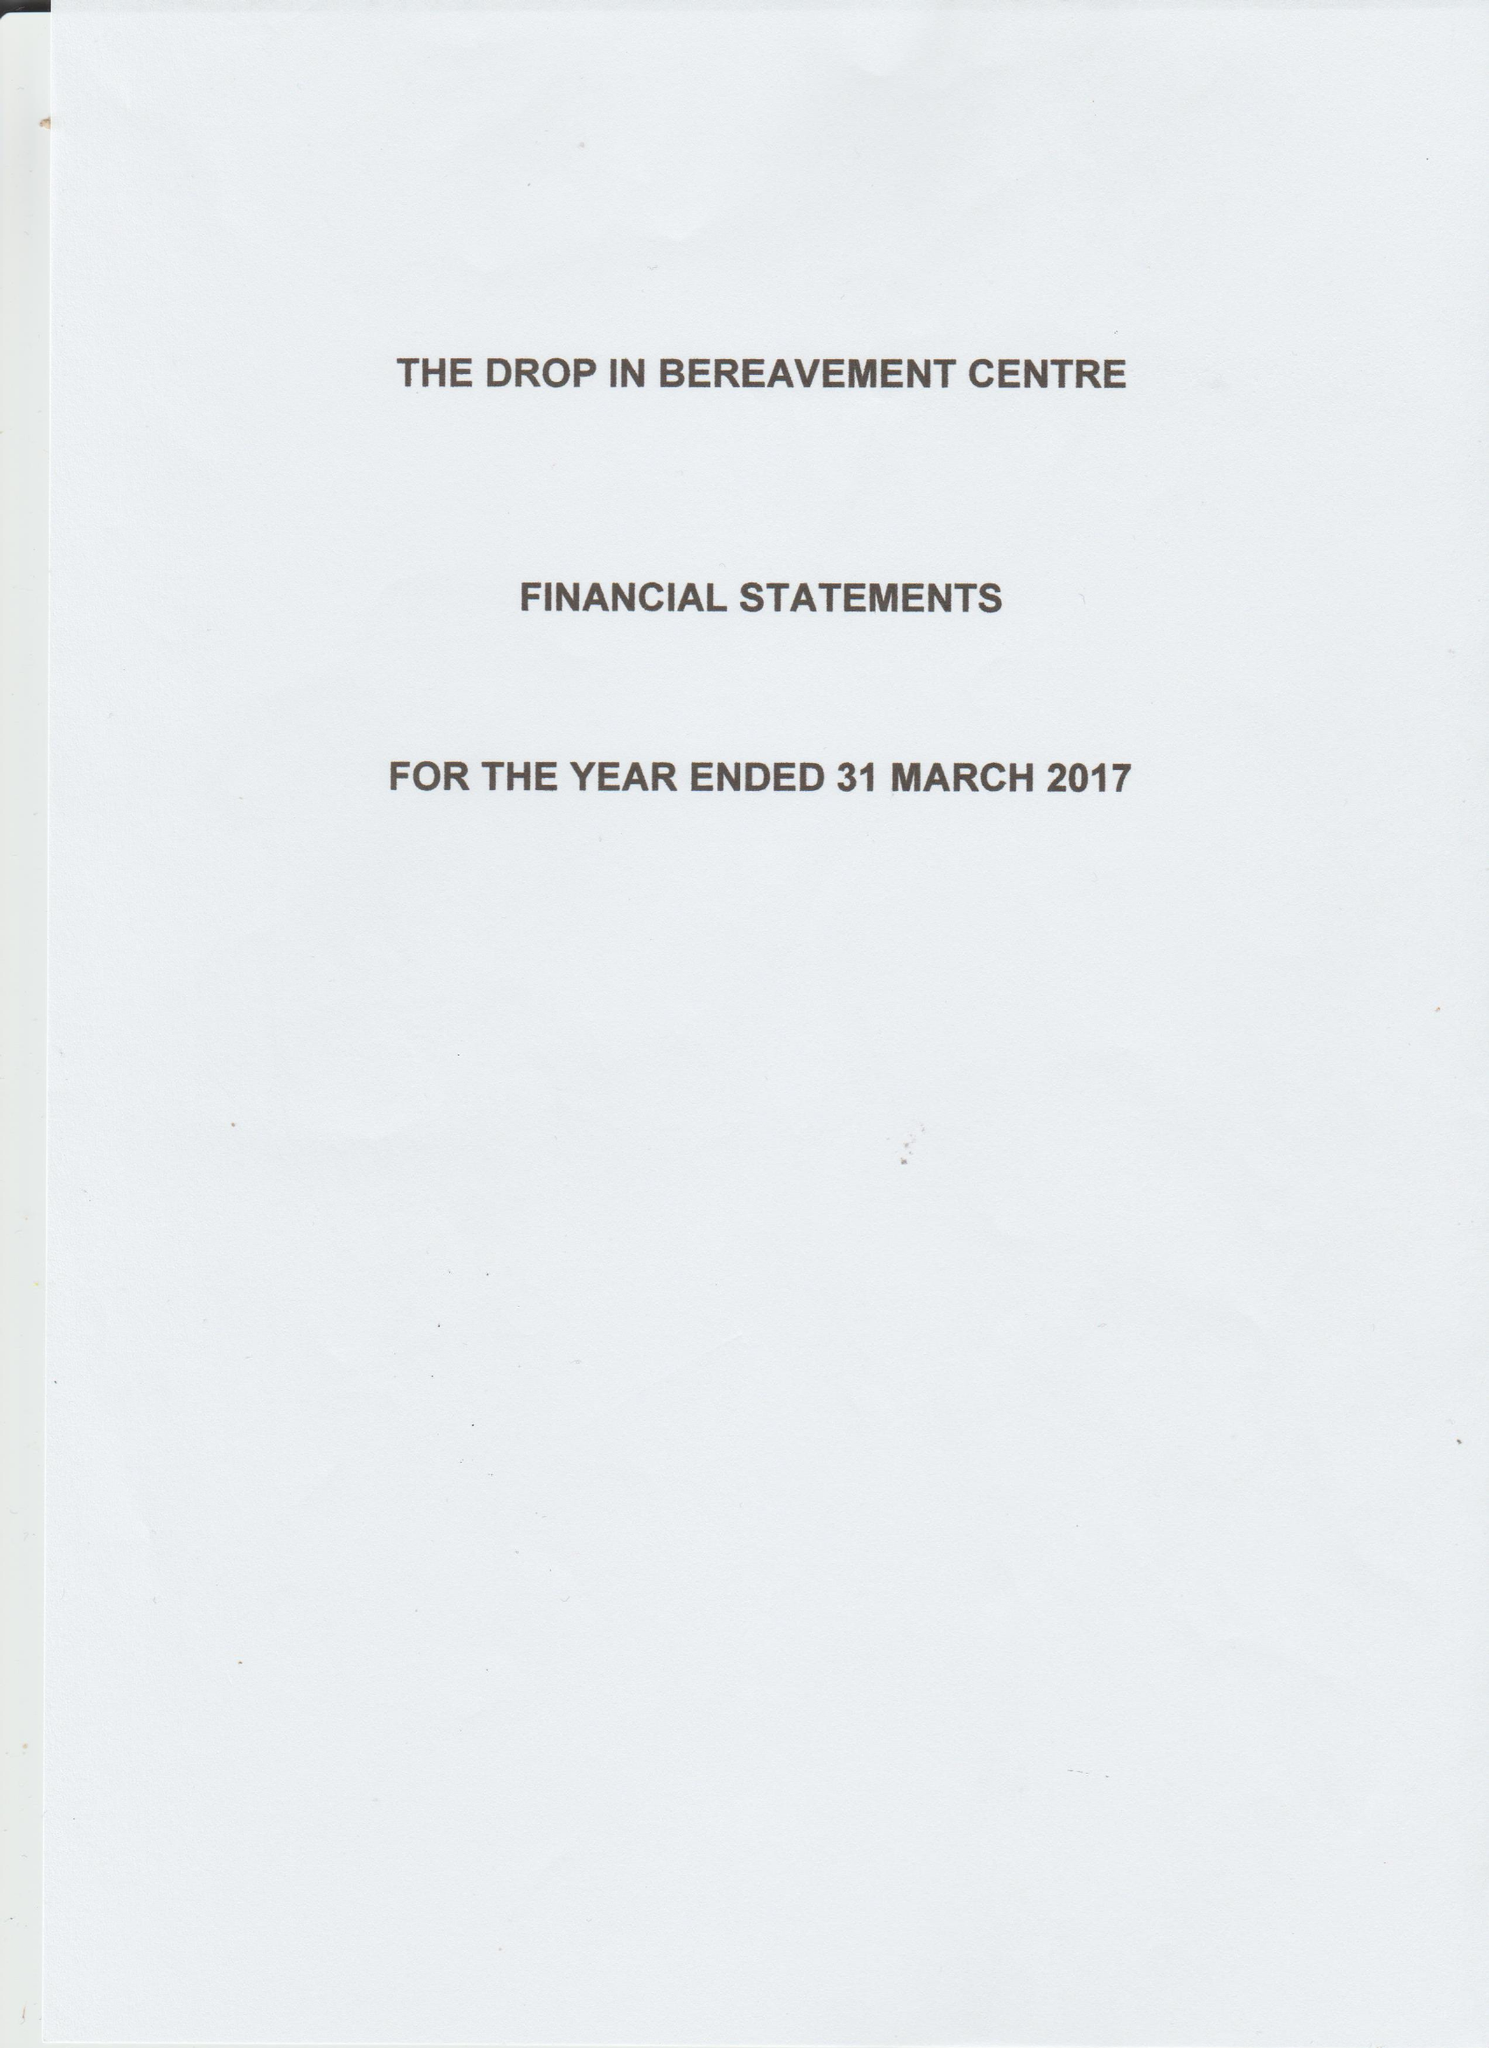What is the value for the spending_annually_in_british_pounds?
Answer the question using a single word or phrase. 36056.78 